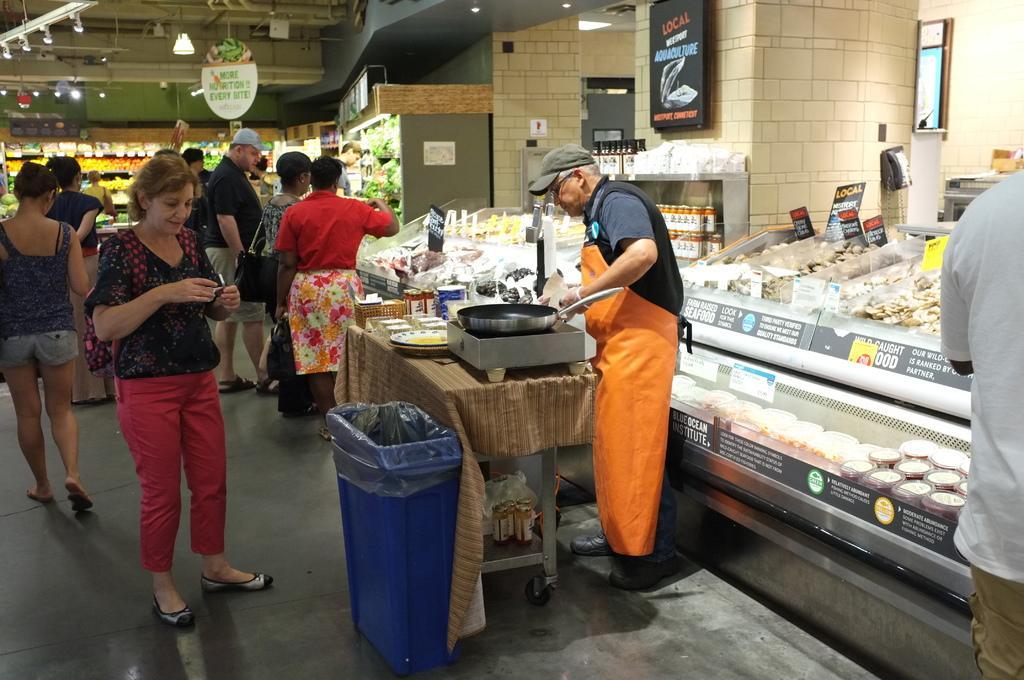Can you describe this image briefly? In this image there are people, lights, racks, glass cupboard, table, bin, stove, plates, pan, cards, jars, board, food and objects. Something is written on the boards and stickers. Under the table there are bottles and things.   